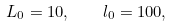<formula> <loc_0><loc_0><loc_500><loc_500>L _ { 0 } = 1 0 , \quad l _ { 0 } = 1 0 0 ,</formula> 